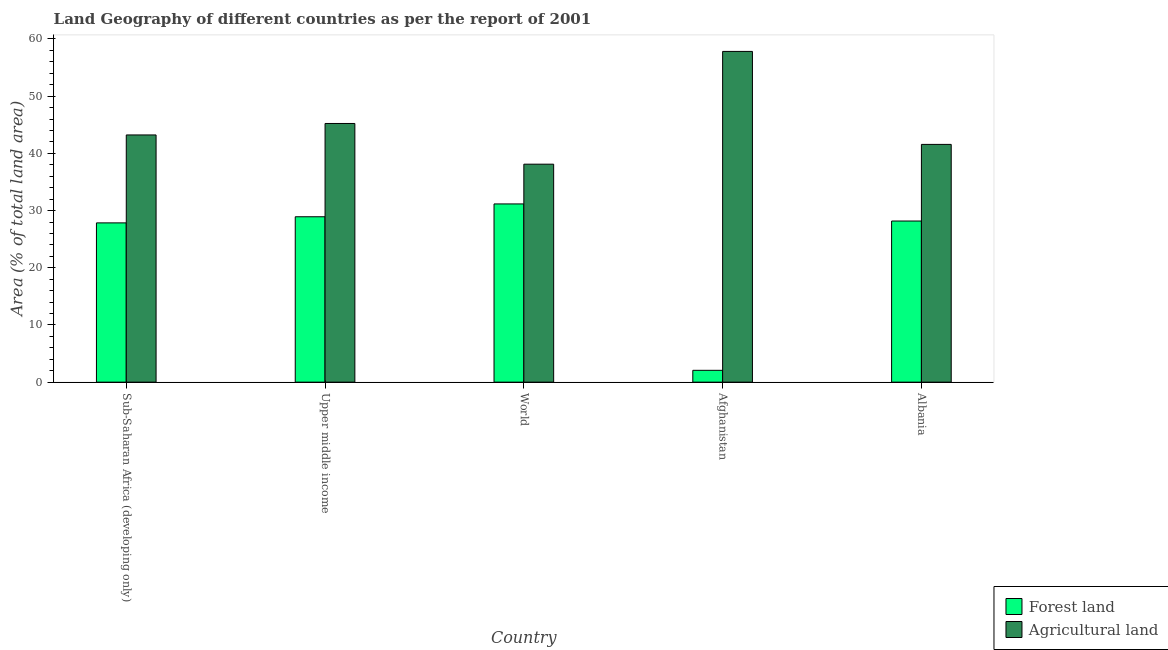How many different coloured bars are there?
Ensure brevity in your answer.  2. How many groups of bars are there?
Your response must be concise. 5. How many bars are there on the 1st tick from the left?
Your answer should be compact. 2. What is the label of the 4th group of bars from the left?
Your response must be concise. Afghanistan. What is the percentage of land area under agriculture in Upper middle income?
Ensure brevity in your answer.  45.23. Across all countries, what is the maximum percentage of land area under forests?
Offer a very short reply. 31.16. Across all countries, what is the minimum percentage of land area under forests?
Ensure brevity in your answer.  2.07. In which country was the percentage of land area under agriculture maximum?
Ensure brevity in your answer.  Afghanistan. In which country was the percentage of land area under agriculture minimum?
Keep it short and to the point. World. What is the total percentage of land area under agriculture in the graph?
Offer a terse response. 225.96. What is the difference between the percentage of land area under forests in Albania and that in Sub-Saharan Africa (developing only)?
Make the answer very short. 0.33. What is the difference between the percentage of land area under forests in Upper middle income and the percentage of land area under agriculture in World?
Your answer should be compact. -9.19. What is the average percentage of land area under forests per country?
Your answer should be compact. 23.63. What is the difference between the percentage of land area under forests and percentage of land area under agriculture in Upper middle income?
Provide a short and direct response. -16.31. What is the ratio of the percentage of land area under agriculture in Sub-Saharan Africa (developing only) to that in Upper middle income?
Offer a terse response. 0.96. Is the difference between the percentage of land area under forests in Afghanistan and Upper middle income greater than the difference between the percentage of land area under agriculture in Afghanistan and Upper middle income?
Your answer should be very brief. No. What is the difference between the highest and the second highest percentage of land area under agriculture?
Offer a terse response. 12.6. What is the difference between the highest and the lowest percentage of land area under agriculture?
Your answer should be compact. 19.72. In how many countries, is the percentage of land area under agriculture greater than the average percentage of land area under agriculture taken over all countries?
Provide a short and direct response. 2. What does the 2nd bar from the left in Upper middle income represents?
Offer a very short reply. Agricultural land. What does the 1st bar from the right in Albania represents?
Provide a short and direct response. Agricultural land. Are all the bars in the graph horizontal?
Make the answer very short. No. How many countries are there in the graph?
Provide a short and direct response. 5. What is the difference between two consecutive major ticks on the Y-axis?
Provide a short and direct response. 10. Does the graph contain grids?
Provide a short and direct response. No. How are the legend labels stacked?
Provide a succinct answer. Vertical. What is the title of the graph?
Offer a terse response. Land Geography of different countries as per the report of 2001. Does "IMF concessional" appear as one of the legend labels in the graph?
Offer a very short reply. No. What is the label or title of the Y-axis?
Your answer should be compact. Area (% of total land area). What is the Area (% of total land area) of Forest land in Sub-Saharan Africa (developing only)?
Keep it short and to the point. 27.85. What is the Area (% of total land area) in Agricultural land in Sub-Saharan Africa (developing only)?
Offer a very short reply. 43.22. What is the Area (% of total land area) in Forest land in Upper middle income?
Provide a succinct answer. 28.92. What is the Area (% of total land area) of Agricultural land in Upper middle income?
Offer a terse response. 45.23. What is the Area (% of total land area) of Forest land in World?
Offer a terse response. 31.16. What is the Area (% of total land area) of Agricultural land in World?
Ensure brevity in your answer.  38.11. What is the Area (% of total land area) in Forest land in Afghanistan?
Keep it short and to the point. 2.07. What is the Area (% of total land area) of Agricultural land in Afghanistan?
Provide a succinct answer. 57.83. What is the Area (% of total land area) of Forest land in Albania?
Ensure brevity in your answer.  28.17. What is the Area (% of total land area) of Agricultural land in Albania?
Your response must be concise. 41.57. Across all countries, what is the maximum Area (% of total land area) of Forest land?
Your answer should be very brief. 31.16. Across all countries, what is the maximum Area (% of total land area) of Agricultural land?
Give a very brief answer. 57.83. Across all countries, what is the minimum Area (% of total land area) in Forest land?
Provide a short and direct response. 2.07. Across all countries, what is the minimum Area (% of total land area) of Agricultural land?
Keep it short and to the point. 38.11. What is the total Area (% of total land area) of Forest land in the graph?
Keep it short and to the point. 118.17. What is the total Area (% of total land area) of Agricultural land in the graph?
Provide a short and direct response. 225.96. What is the difference between the Area (% of total land area) of Forest land in Sub-Saharan Africa (developing only) and that in Upper middle income?
Make the answer very short. -1.07. What is the difference between the Area (% of total land area) of Agricultural land in Sub-Saharan Africa (developing only) and that in Upper middle income?
Ensure brevity in your answer.  -2.01. What is the difference between the Area (% of total land area) in Forest land in Sub-Saharan Africa (developing only) and that in World?
Ensure brevity in your answer.  -3.31. What is the difference between the Area (% of total land area) in Agricultural land in Sub-Saharan Africa (developing only) and that in World?
Give a very brief answer. 5.11. What is the difference between the Area (% of total land area) of Forest land in Sub-Saharan Africa (developing only) and that in Afghanistan?
Make the answer very short. 25.78. What is the difference between the Area (% of total land area) of Agricultural land in Sub-Saharan Africa (developing only) and that in Afghanistan?
Offer a terse response. -14.61. What is the difference between the Area (% of total land area) of Forest land in Sub-Saharan Africa (developing only) and that in Albania?
Offer a very short reply. -0.33. What is the difference between the Area (% of total land area) in Agricultural land in Sub-Saharan Africa (developing only) and that in Albania?
Your response must be concise. 1.65. What is the difference between the Area (% of total land area) in Forest land in Upper middle income and that in World?
Offer a very short reply. -2.24. What is the difference between the Area (% of total land area) in Agricultural land in Upper middle income and that in World?
Provide a succinct answer. 7.12. What is the difference between the Area (% of total land area) in Forest land in Upper middle income and that in Afghanistan?
Ensure brevity in your answer.  26.85. What is the difference between the Area (% of total land area) in Agricultural land in Upper middle income and that in Afghanistan?
Offer a very short reply. -12.6. What is the difference between the Area (% of total land area) of Forest land in Upper middle income and that in Albania?
Give a very brief answer. 0.75. What is the difference between the Area (% of total land area) of Agricultural land in Upper middle income and that in Albania?
Your answer should be very brief. 3.66. What is the difference between the Area (% of total land area) in Forest land in World and that in Afghanistan?
Offer a very short reply. 29.09. What is the difference between the Area (% of total land area) in Agricultural land in World and that in Afghanistan?
Make the answer very short. -19.72. What is the difference between the Area (% of total land area) of Forest land in World and that in Albania?
Your response must be concise. 2.99. What is the difference between the Area (% of total land area) in Agricultural land in World and that in Albania?
Offer a terse response. -3.46. What is the difference between the Area (% of total land area) in Forest land in Afghanistan and that in Albania?
Your answer should be very brief. -26.1. What is the difference between the Area (% of total land area) in Agricultural land in Afghanistan and that in Albania?
Give a very brief answer. 16.26. What is the difference between the Area (% of total land area) of Forest land in Sub-Saharan Africa (developing only) and the Area (% of total land area) of Agricultural land in Upper middle income?
Provide a short and direct response. -17.38. What is the difference between the Area (% of total land area) of Forest land in Sub-Saharan Africa (developing only) and the Area (% of total land area) of Agricultural land in World?
Your response must be concise. -10.26. What is the difference between the Area (% of total land area) in Forest land in Sub-Saharan Africa (developing only) and the Area (% of total land area) in Agricultural land in Afghanistan?
Offer a very short reply. -29.98. What is the difference between the Area (% of total land area) of Forest land in Sub-Saharan Africa (developing only) and the Area (% of total land area) of Agricultural land in Albania?
Offer a very short reply. -13.72. What is the difference between the Area (% of total land area) in Forest land in Upper middle income and the Area (% of total land area) in Agricultural land in World?
Your answer should be very brief. -9.19. What is the difference between the Area (% of total land area) of Forest land in Upper middle income and the Area (% of total land area) of Agricultural land in Afghanistan?
Provide a short and direct response. -28.91. What is the difference between the Area (% of total land area) in Forest land in Upper middle income and the Area (% of total land area) in Agricultural land in Albania?
Your answer should be compact. -12.65. What is the difference between the Area (% of total land area) in Forest land in World and the Area (% of total land area) in Agricultural land in Afghanistan?
Give a very brief answer. -26.67. What is the difference between the Area (% of total land area) of Forest land in World and the Area (% of total land area) of Agricultural land in Albania?
Your answer should be compact. -10.41. What is the difference between the Area (% of total land area) of Forest land in Afghanistan and the Area (% of total land area) of Agricultural land in Albania?
Your answer should be very brief. -39.5. What is the average Area (% of total land area) of Forest land per country?
Provide a short and direct response. 23.63. What is the average Area (% of total land area) in Agricultural land per country?
Your answer should be compact. 45.19. What is the difference between the Area (% of total land area) in Forest land and Area (% of total land area) in Agricultural land in Sub-Saharan Africa (developing only)?
Offer a terse response. -15.37. What is the difference between the Area (% of total land area) of Forest land and Area (% of total land area) of Agricultural land in Upper middle income?
Ensure brevity in your answer.  -16.31. What is the difference between the Area (% of total land area) of Forest land and Area (% of total land area) of Agricultural land in World?
Give a very brief answer. -6.95. What is the difference between the Area (% of total land area) of Forest land and Area (% of total land area) of Agricultural land in Afghanistan?
Offer a terse response. -55.76. What is the difference between the Area (% of total land area) in Forest land and Area (% of total land area) in Agricultural land in Albania?
Ensure brevity in your answer.  -13.4. What is the ratio of the Area (% of total land area) in Forest land in Sub-Saharan Africa (developing only) to that in Upper middle income?
Provide a short and direct response. 0.96. What is the ratio of the Area (% of total land area) of Agricultural land in Sub-Saharan Africa (developing only) to that in Upper middle income?
Your answer should be compact. 0.96. What is the ratio of the Area (% of total land area) of Forest land in Sub-Saharan Africa (developing only) to that in World?
Your answer should be very brief. 0.89. What is the ratio of the Area (% of total land area) in Agricultural land in Sub-Saharan Africa (developing only) to that in World?
Give a very brief answer. 1.13. What is the ratio of the Area (% of total land area) in Forest land in Sub-Saharan Africa (developing only) to that in Afghanistan?
Ensure brevity in your answer.  13.47. What is the ratio of the Area (% of total land area) of Agricultural land in Sub-Saharan Africa (developing only) to that in Afghanistan?
Provide a short and direct response. 0.75. What is the ratio of the Area (% of total land area) of Forest land in Sub-Saharan Africa (developing only) to that in Albania?
Offer a very short reply. 0.99. What is the ratio of the Area (% of total land area) of Agricultural land in Sub-Saharan Africa (developing only) to that in Albania?
Your answer should be compact. 1.04. What is the ratio of the Area (% of total land area) in Forest land in Upper middle income to that in World?
Make the answer very short. 0.93. What is the ratio of the Area (% of total land area) of Agricultural land in Upper middle income to that in World?
Your answer should be compact. 1.19. What is the ratio of the Area (% of total land area) in Forest land in Upper middle income to that in Afghanistan?
Your response must be concise. 13.98. What is the ratio of the Area (% of total land area) in Agricultural land in Upper middle income to that in Afghanistan?
Your answer should be very brief. 0.78. What is the ratio of the Area (% of total land area) of Forest land in Upper middle income to that in Albania?
Give a very brief answer. 1.03. What is the ratio of the Area (% of total land area) of Agricultural land in Upper middle income to that in Albania?
Ensure brevity in your answer.  1.09. What is the ratio of the Area (% of total land area) in Forest land in World to that in Afghanistan?
Keep it short and to the point. 15.07. What is the ratio of the Area (% of total land area) of Agricultural land in World to that in Afghanistan?
Offer a terse response. 0.66. What is the ratio of the Area (% of total land area) in Forest land in World to that in Albania?
Make the answer very short. 1.11. What is the ratio of the Area (% of total land area) in Agricultural land in World to that in Albania?
Give a very brief answer. 0.92. What is the ratio of the Area (% of total land area) in Forest land in Afghanistan to that in Albania?
Provide a short and direct response. 0.07. What is the ratio of the Area (% of total land area) in Agricultural land in Afghanistan to that in Albania?
Provide a short and direct response. 1.39. What is the difference between the highest and the second highest Area (% of total land area) in Forest land?
Give a very brief answer. 2.24. What is the difference between the highest and the second highest Area (% of total land area) in Agricultural land?
Give a very brief answer. 12.6. What is the difference between the highest and the lowest Area (% of total land area) of Forest land?
Your answer should be compact. 29.09. What is the difference between the highest and the lowest Area (% of total land area) in Agricultural land?
Offer a terse response. 19.72. 